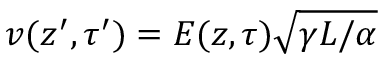Convert formula to latex. <formula><loc_0><loc_0><loc_500><loc_500>v ( z ^ { \prime } , \tau ^ { \prime } ) = E ( z , \tau ) \sqrt { \gamma L / \alpha }</formula> 